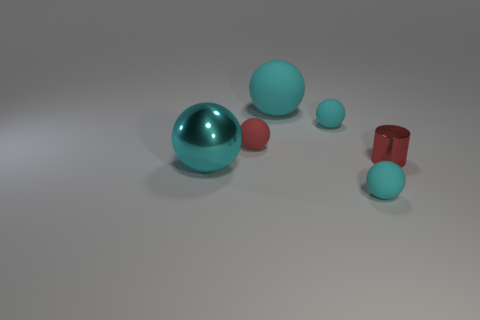Do the tiny object that is behind the small red matte object and the cyan shiny thing have the same shape?
Ensure brevity in your answer.  Yes. What number of things are either big rubber things or cyan spheres that are in front of the tiny metal cylinder?
Provide a succinct answer. 3. Is the number of small balls that are in front of the big metallic ball greater than the number of tiny purple cubes?
Provide a short and direct response. Yes. Are there an equal number of cyan balls in front of the red matte thing and small cyan balls to the right of the big cyan metal object?
Make the answer very short. Yes. There is a tiny red thing that is to the left of the big rubber ball; is there a cyan metallic ball behind it?
Offer a very short reply. No. The tiny red metal object is what shape?
Offer a very short reply. Cylinder. What is the size of the matte object that is the same color as the shiny cylinder?
Give a very brief answer. Small. What size is the shiny thing that is on the left side of the tiny thing that is in front of the red metallic thing?
Give a very brief answer. Large. There is a cyan thing left of the large cyan matte object; how big is it?
Make the answer very short. Large. Are there fewer tiny cyan balls in front of the shiny cylinder than big shiny spheres right of the large cyan metallic object?
Offer a terse response. No. 